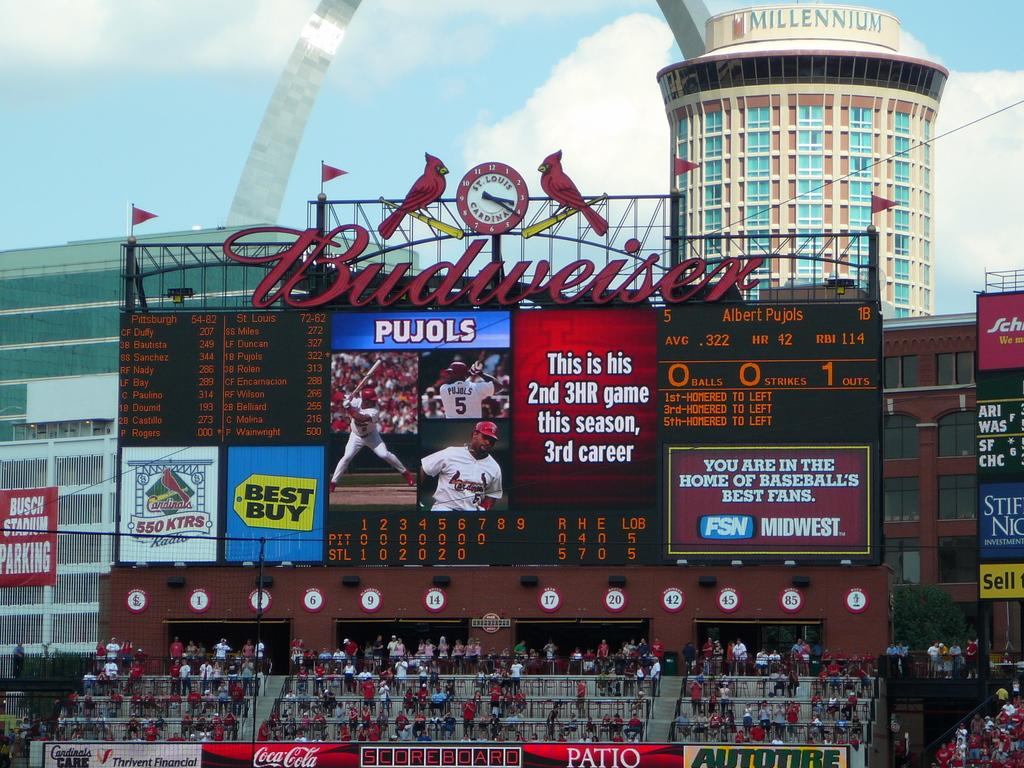What type of boards are present in the image? There are digital boards and regular boards in the image. What can be seen on the boards? The screens on the digital boards display information or images. What else is present in the image besides the boards? There are trees, people, hoardings, buildings, and unspecified objects in the image. What is the condition of the sky in the image? The sky is cloudy in the image. How many lizards are crawling on the digital boards in the image? There are no lizards present in the image. What type of alarm is set off by the people in the image? There is no alarm present in the image. 